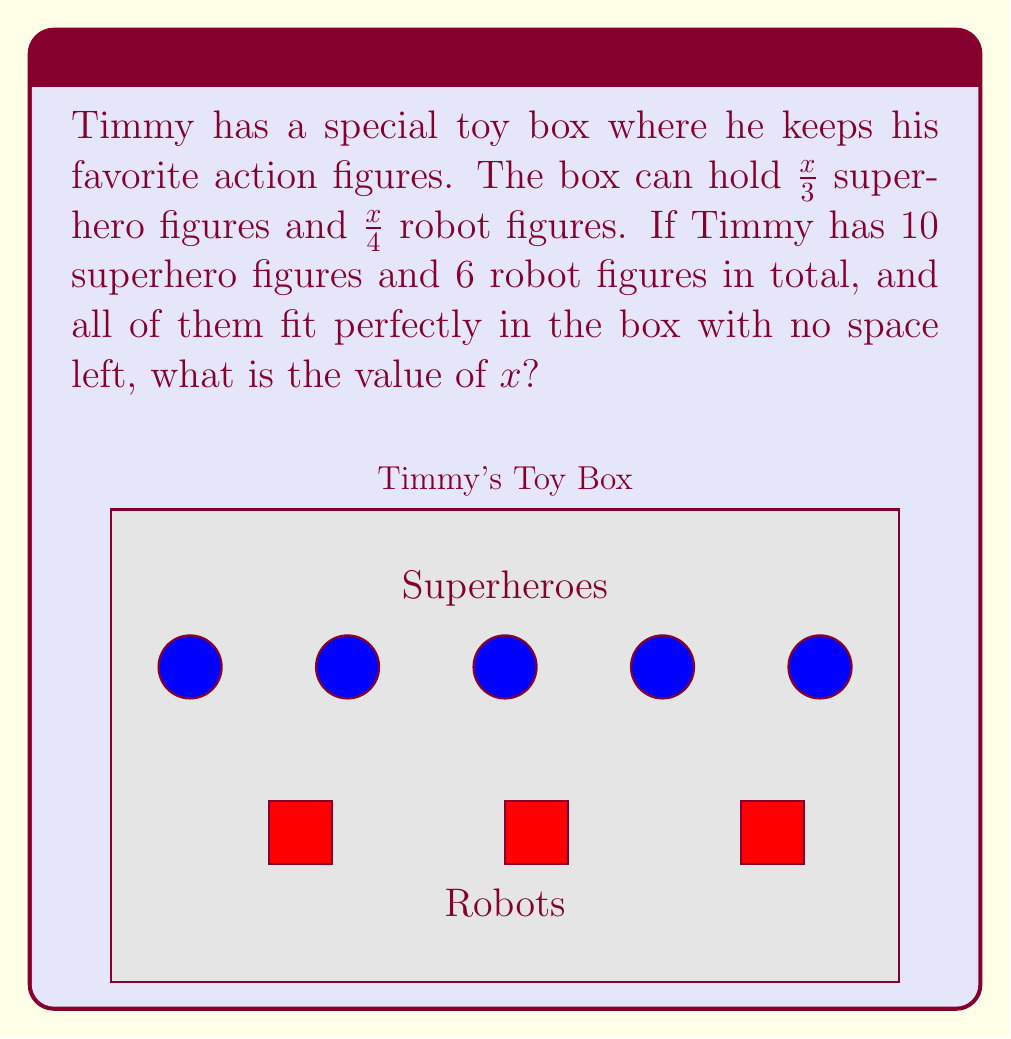Solve this math problem. Let's solve this step-by-step:

1) First, we need to set up an equation based on the information given:
   $$\frac{x}{3} + \frac{x}{4} = 10 + 6 = 16$$

2) Now, we need to find a common denominator to add the fractions on the left side:
   $$\frac{4x}{12} + \frac{3x}{12} = 16$$

3) Add the fractions on the left side:
   $$\frac{7x}{12} = 16$$

4) Multiply both sides by 12 to isolate $x$:
   $$7x = 16 \cdot 12 = 192$$

5) Finally, divide both sides by 7:
   $$x = \frac{192}{7} = 27.4285...$$

6) Since $x$ represents the total capacity of the box and we're dealing with whole toy figures, we need to round to the nearest whole number:
   $$x \approx 27$$

7) We can verify:
   $\frac{27}{3} = 9$ superhero figures
   $\frac{27}{4} = 6.75 \approx 7$ robot figures
   $9 + 7 = 16$ total figures, which matches our problem.
Answer: $x = 27$ 